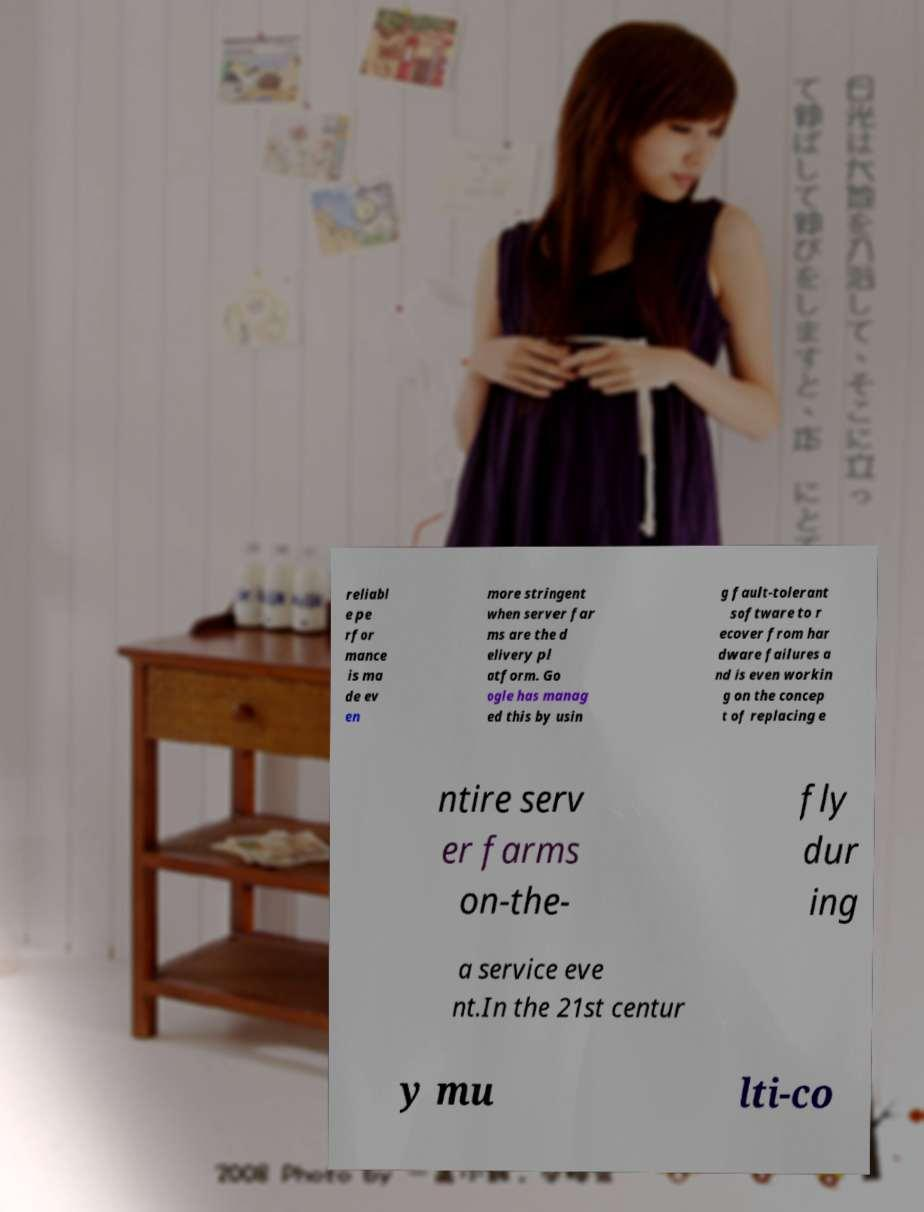Can you read and provide the text displayed in the image?This photo seems to have some interesting text. Can you extract and type it out for me? reliabl e pe rfor mance is ma de ev en more stringent when server far ms are the d elivery pl atform. Go ogle has manag ed this by usin g fault-tolerant software to r ecover from har dware failures a nd is even workin g on the concep t of replacing e ntire serv er farms on-the- fly dur ing a service eve nt.In the 21st centur y mu lti-co 